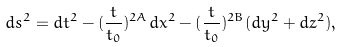Convert formula to latex. <formula><loc_0><loc_0><loc_500><loc_500>d s ^ { 2 } = d t ^ { 2 } - ( \frac { t } { t _ { 0 } } ) ^ { 2 A } d x ^ { 2 } - ( \frac { t } { t _ { 0 } } ) ^ { 2 B } ( d y ^ { 2 } + d z ^ { 2 } ) ,</formula> 